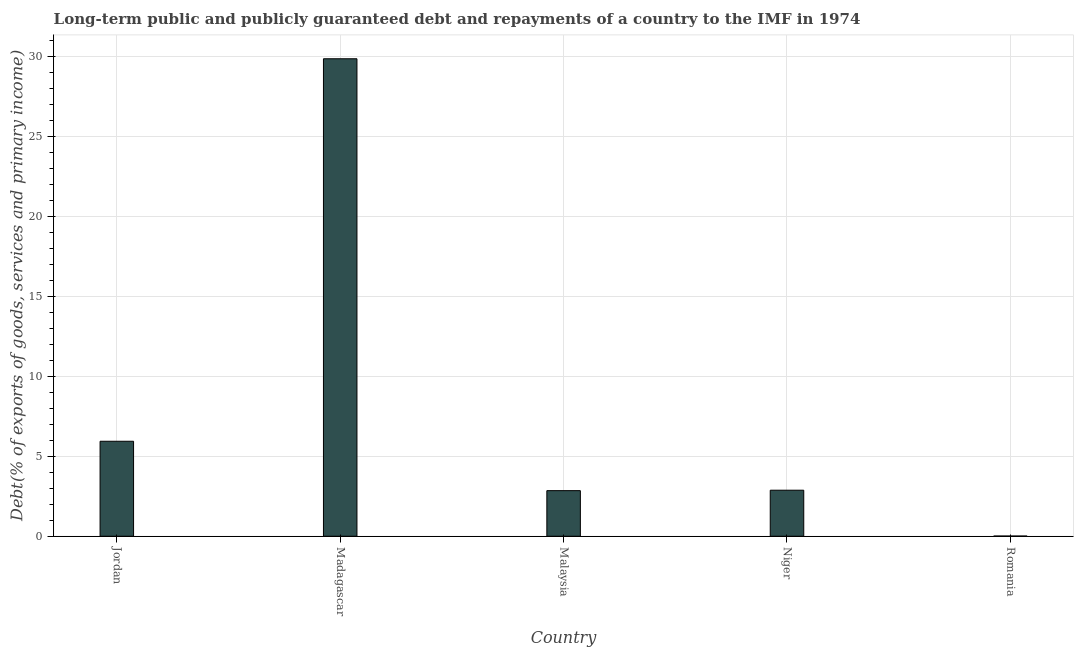What is the title of the graph?
Make the answer very short. Long-term public and publicly guaranteed debt and repayments of a country to the IMF in 1974. What is the label or title of the X-axis?
Your response must be concise. Country. What is the label or title of the Y-axis?
Provide a short and direct response. Debt(% of exports of goods, services and primary income). What is the debt service in Madagascar?
Provide a succinct answer. 29.88. Across all countries, what is the maximum debt service?
Make the answer very short. 29.88. Across all countries, what is the minimum debt service?
Provide a short and direct response. 0.01. In which country was the debt service maximum?
Your answer should be very brief. Madagascar. In which country was the debt service minimum?
Your answer should be very brief. Romania. What is the sum of the debt service?
Your answer should be compact. 41.57. What is the difference between the debt service in Madagascar and Romania?
Make the answer very short. 29.86. What is the average debt service per country?
Ensure brevity in your answer.  8.31. What is the median debt service?
Your response must be concise. 2.88. In how many countries, is the debt service greater than 4 %?
Your response must be concise. 2. What is the ratio of the debt service in Madagascar to that in Niger?
Your answer should be very brief. 10.37. What is the difference between the highest and the second highest debt service?
Your answer should be very brief. 23.93. What is the difference between the highest and the lowest debt service?
Provide a succinct answer. 29.86. Are all the bars in the graph horizontal?
Provide a succinct answer. No. How many countries are there in the graph?
Your response must be concise. 5. Are the values on the major ticks of Y-axis written in scientific E-notation?
Make the answer very short. No. What is the Debt(% of exports of goods, services and primary income) in Jordan?
Your response must be concise. 5.94. What is the Debt(% of exports of goods, services and primary income) of Madagascar?
Keep it short and to the point. 29.88. What is the Debt(% of exports of goods, services and primary income) of Malaysia?
Make the answer very short. 2.85. What is the Debt(% of exports of goods, services and primary income) in Niger?
Offer a very short reply. 2.88. What is the Debt(% of exports of goods, services and primary income) of Romania?
Offer a very short reply. 0.01. What is the difference between the Debt(% of exports of goods, services and primary income) in Jordan and Madagascar?
Provide a short and direct response. -23.93. What is the difference between the Debt(% of exports of goods, services and primary income) in Jordan and Malaysia?
Offer a terse response. 3.09. What is the difference between the Debt(% of exports of goods, services and primary income) in Jordan and Niger?
Your answer should be compact. 3.06. What is the difference between the Debt(% of exports of goods, services and primary income) in Jordan and Romania?
Provide a succinct answer. 5.93. What is the difference between the Debt(% of exports of goods, services and primary income) in Madagascar and Malaysia?
Offer a very short reply. 27.02. What is the difference between the Debt(% of exports of goods, services and primary income) in Madagascar and Niger?
Give a very brief answer. 27. What is the difference between the Debt(% of exports of goods, services and primary income) in Madagascar and Romania?
Offer a very short reply. 29.86. What is the difference between the Debt(% of exports of goods, services and primary income) in Malaysia and Niger?
Provide a short and direct response. -0.03. What is the difference between the Debt(% of exports of goods, services and primary income) in Malaysia and Romania?
Ensure brevity in your answer.  2.84. What is the difference between the Debt(% of exports of goods, services and primary income) in Niger and Romania?
Your answer should be very brief. 2.87. What is the ratio of the Debt(% of exports of goods, services and primary income) in Jordan to that in Madagascar?
Your answer should be very brief. 0.2. What is the ratio of the Debt(% of exports of goods, services and primary income) in Jordan to that in Malaysia?
Your answer should be compact. 2.08. What is the ratio of the Debt(% of exports of goods, services and primary income) in Jordan to that in Niger?
Make the answer very short. 2.06. What is the ratio of the Debt(% of exports of goods, services and primary income) in Jordan to that in Romania?
Provide a succinct answer. 408.74. What is the ratio of the Debt(% of exports of goods, services and primary income) in Madagascar to that in Malaysia?
Your answer should be compact. 10.47. What is the ratio of the Debt(% of exports of goods, services and primary income) in Madagascar to that in Niger?
Your response must be concise. 10.37. What is the ratio of the Debt(% of exports of goods, services and primary income) in Madagascar to that in Romania?
Offer a terse response. 2054.55. What is the ratio of the Debt(% of exports of goods, services and primary income) in Malaysia to that in Niger?
Your response must be concise. 0.99. What is the ratio of the Debt(% of exports of goods, services and primary income) in Malaysia to that in Romania?
Provide a succinct answer. 196.19. What is the ratio of the Debt(% of exports of goods, services and primary income) in Niger to that in Romania?
Provide a short and direct response. 198.11. 